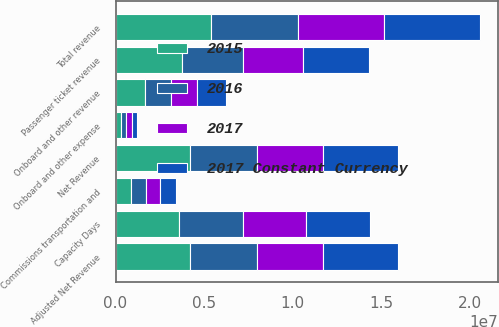<chart> <loc_0><loc_0><loc_500><loc_500><stacked_bar_chart><ecel><fcel>Passenger ticket revenue<fcel>Onboard and other revenue<fcel>Total revenue<fcel>Commissions transportation and<fcel>Onboard and other expense<fcel>Net Revenue<fcel>Adjusted Net Revenue<fcel>Capacity Days<nl><fcel>2015<fcel>3.75003e+06<fcel>1.64614e+06<fcel>5.39618e+06<fcel>894406<fcel>319293<fcel>4.18248e+06<fcel>4.18248e+06<fcel>3.58549e+06<nl><fcel>2017 Constant Currency<fcel>3.76089e+06<fcel>1.64614e+06<fcel>5.40703e+06<fcel>896985<fcel>319293<fcel>4.19075e+06<fcel>4.19075e+06<fcel>3.58549e+06<nl><fcel>2017<fcel>3.38895e+06<fcel>1.48539e+06<fcel>4.87434e+06<fcel>813559<fcel>298886<fcel>3.7619e+06<fcel>3.76295e+06<fcel>3.58549e+06<nl><fcel>2016<fcel>3.42096e+06<fcel>1.48539e+06<fcel>4.90634e+06<fcel>821608<fcel>298886<fcel>3.78585e+06<fcel>3.78691e+06<fcel>3.58549e+06<nl></chart> 